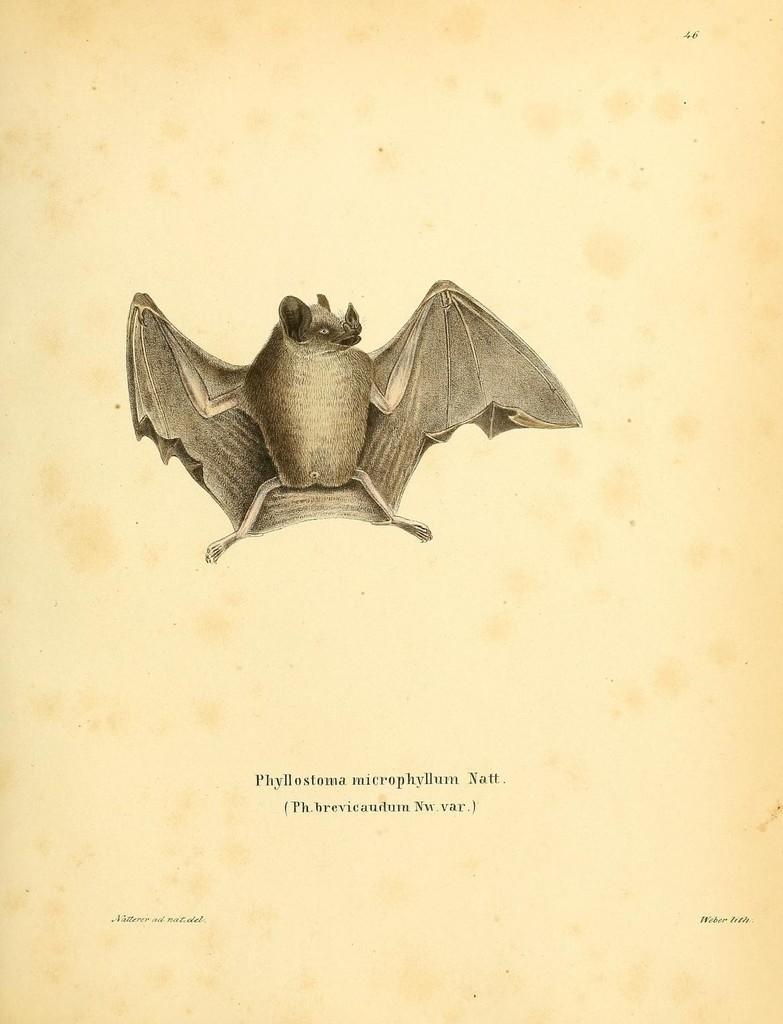Could you give a brief overview of what you see in this image? In this picture I can see a painting and there is a bat here and there is something written at the bottom. 